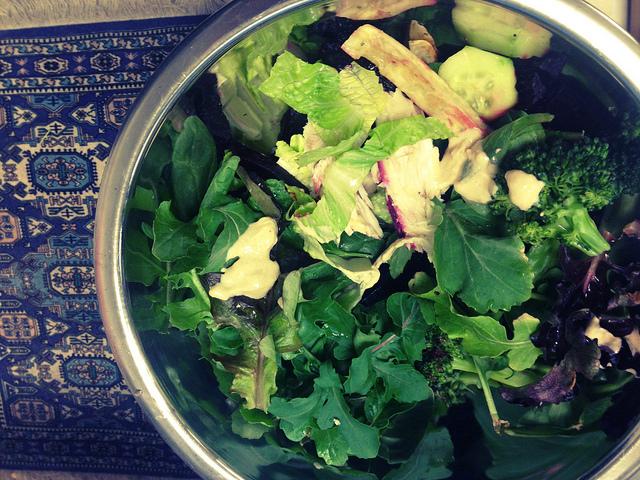Does this look like a healthy meal?
Answer briefly. Yes. Is this healthy?
Quick response, please. Yes. Where is the broccoli?
Write a very short answer. Bowl. 